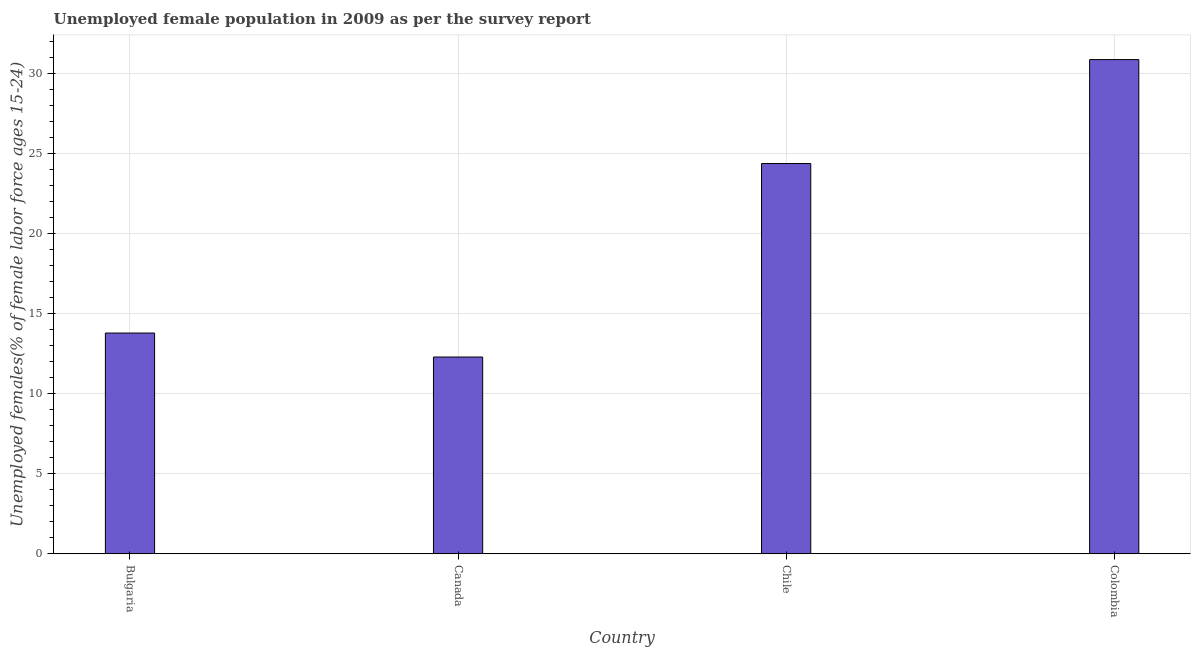Does the graph contain any zero values?
Offer a very short reply. No. What is the title of the graph?
Make the answer very short. Unemployed female population in 2009 as per the survey report. What is the label or title of the X-axis?
Your answer should be very brief. Country. What is the label or title of the Y-axis?
Offer a terse response. Unemployed females(% of female labor force ages 15-24). What is the unemployed female youth in Canada?
Your answer should be very brief. 12.3. Across all countries, what is the maximum unemployed female youth?
Offer a terse response. 30.9. Across all countries, what is the minimum unemployed female youth?
Give a very brief answer. 12.3. What is the sum of the unemployed female youth?
Offer a very short reply. 81.4. What is the difference between the unemployed female youth in Bulgaria and Canada?
Your response must be concise. 1.5. What is the average unemployed female youth per country?
Offer a very short reply. 20.35. What is the median unemployed female youth?
Offer a terse response. 19.1. In how many countries, is the unemployed female youth greater than 15 %?
Ensure brevity in your answer.  2. What is the ratio of the unemployed female youth in Bulgaria to that in Canada?
Provide a succinct answer. 1.12. What is the difference between the highest and the second highest unemployed female youth?
Ensure brevity in your answer.  6.5. Is the sum of the unemployed female youth in Canada and Colombia greater than the maximum unemployed female youth across all countries?
Provide a short and direct response. Yes. What is the difference between the highest and the lowest unemployed female youth?
Provide a succinct answer. 18.6. How many bars are there?
Keep it short and to the point. 4. Are all the bars in the graph horizontal?
Give a very brief answer. No. How many countries are there in the graph?
Make the answer very short. 4. What is the difference between two consecutive major ticks on the Y-axis?
Ensure brevity in your answer.  5. What is the Unemployed females(% of female labor force ages 15-24) of Bulgaria?
Your answer should be compact. 13.8. What is the Unemployed females(% of female labor force ages 15-24) of Canada?
Provide a short and direct response. 12.3. What is the Unemployed females(% of female labor force ages 15-24) of Chile?
Your answer should be very brief. 24.4. What is the Unemployed females(% of female labor force ages 15-24) of Colombia?
Ensure brevity in your answer.  30.9. What is the difference between the Unemployed females(% of female labor force ages 15-24) in Bulgaria and Chile?
Ensure brevity in your answer.  -10.6. What is the difference between the Unemployed females(% of female labor force ages 15-24) in Bulgaria and Colombia?
Keep it short and to the point. -17.1. What is the difference between the Unemployed females(% of female labor force ages 15-24) in Canada and Colombia?
Your response must be concise. -18.6. What is the difference between the Unemployed females(% of female labor force ages 15-24) in Chile and Colombia?
Provide a short and direct response. -6.5. What is the ratio of the Unemployed females(% of female labor force ages 15-24) in Bulgaria to that in Canada?
Provide a succinct answer. 1.12. What is the ratio of the Unemployed females(% of female labor force ages 15-24) in Bulgaria to that in Chile?
Provide a short and direct response. 0.57. What is the ratio of the Unemployed females(% of female labor force ages 15-24) in Bulgaria to that in Colombia?
Give a very brief answer. 0.45. What is the ratio of the Unemployed females(% of female labor force ages 15-24) in Canada to that in Chile?
Offer a very short reply. 0.5. What is the ratio of the Unemployed females(% of female labor force ages 15-24) in Canada to that in Colombia?
Your answer should be compact. 0.4. What is the ratio of the Unemployed females(% of female labor force ages 15-24) in Chile to that in Colombia?
Keep it short and to the point. 0.79. 